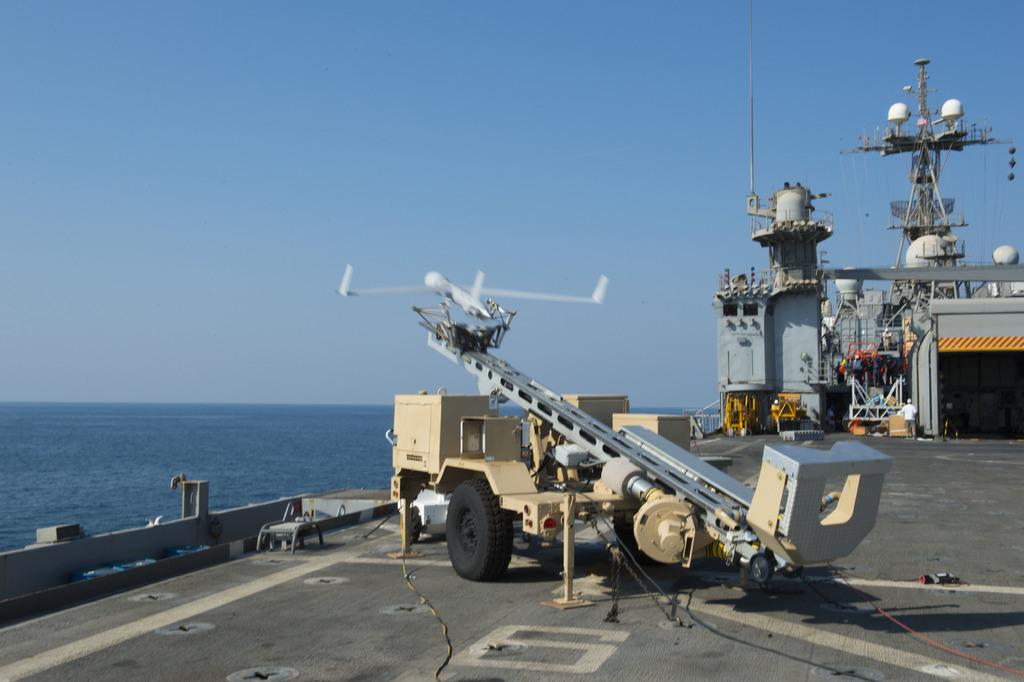What type of large vehicle is present in the image? There is a battleship in the image. What other type of vehicle can be seen in the image? There is a vehicle in the image. What natural element is visible in the image? Water is visible in the image. What is visible at the top of the image? The sky is visible at the top of the image. Where is the needle used for sewing in the image? There is no needle present in the image. What type of farming equipment can be seen in the image? There is no farming equipment, such as a plough, present in the image. 